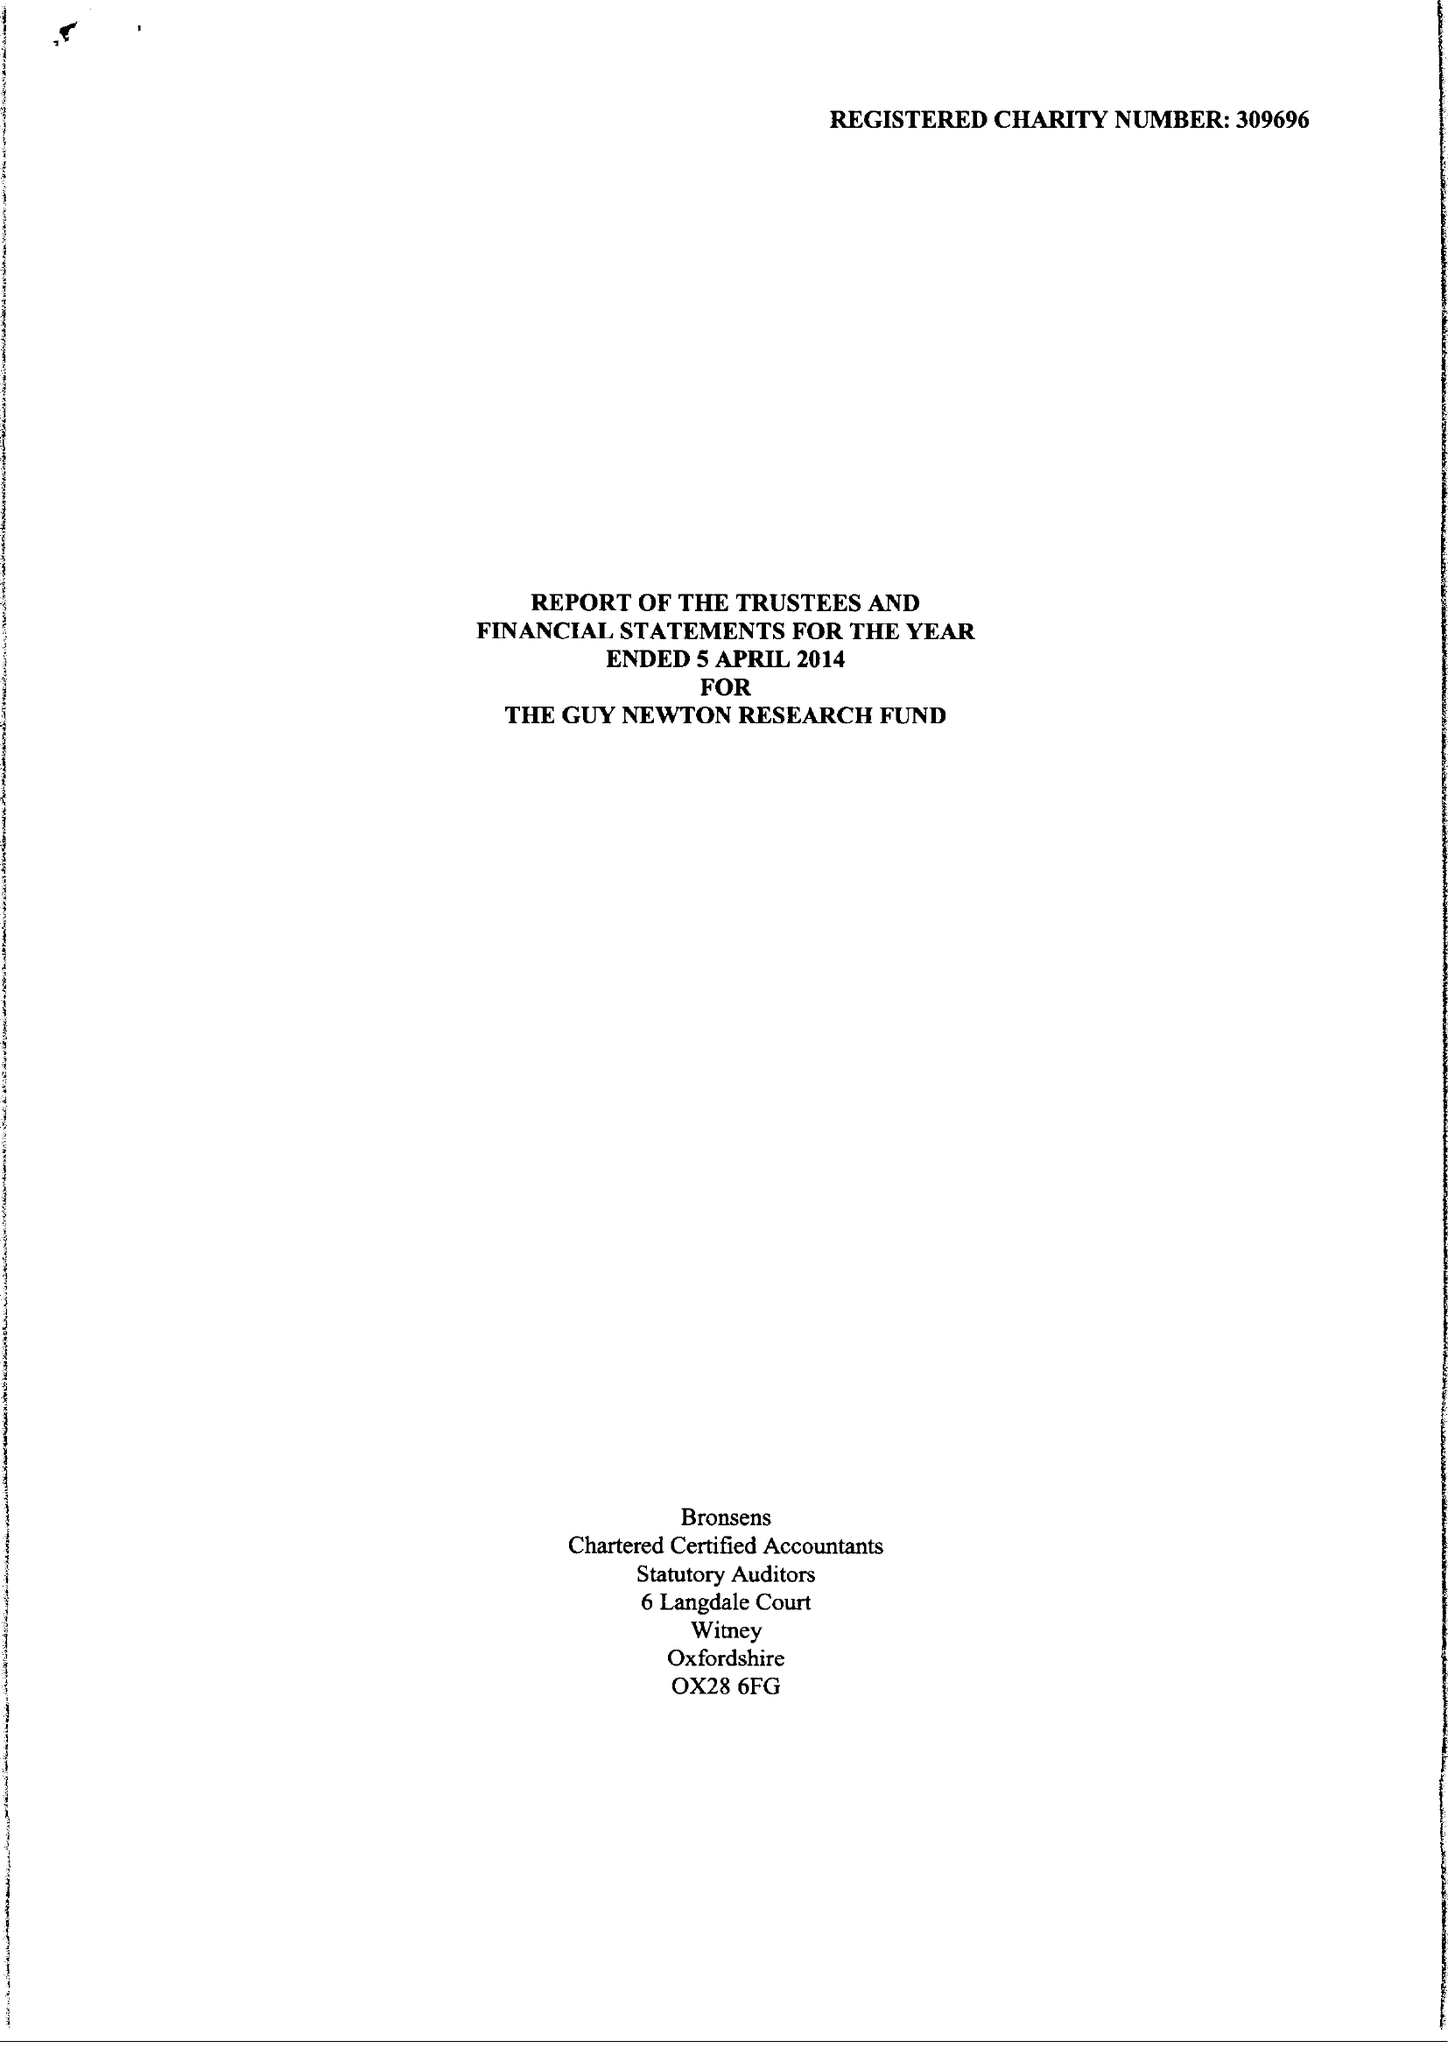What is the value for the address__street_line?
Answer the question using a single word or phrase. SOUTH PARKS ROAD 